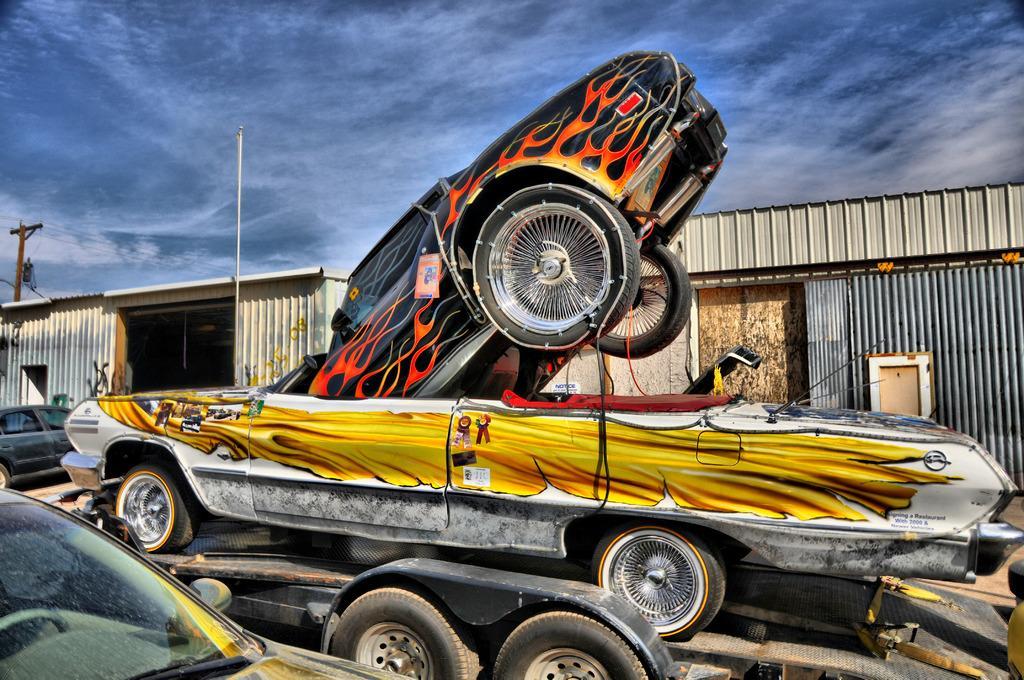Please provide a concise description of this image. Here in this picture we can see a car present on a truck and on that also we can see another car present and we can see other cars also present on the ground over there and beside it we can see sheds present and we can see an electric pole and we can see clouds in sky over there. 